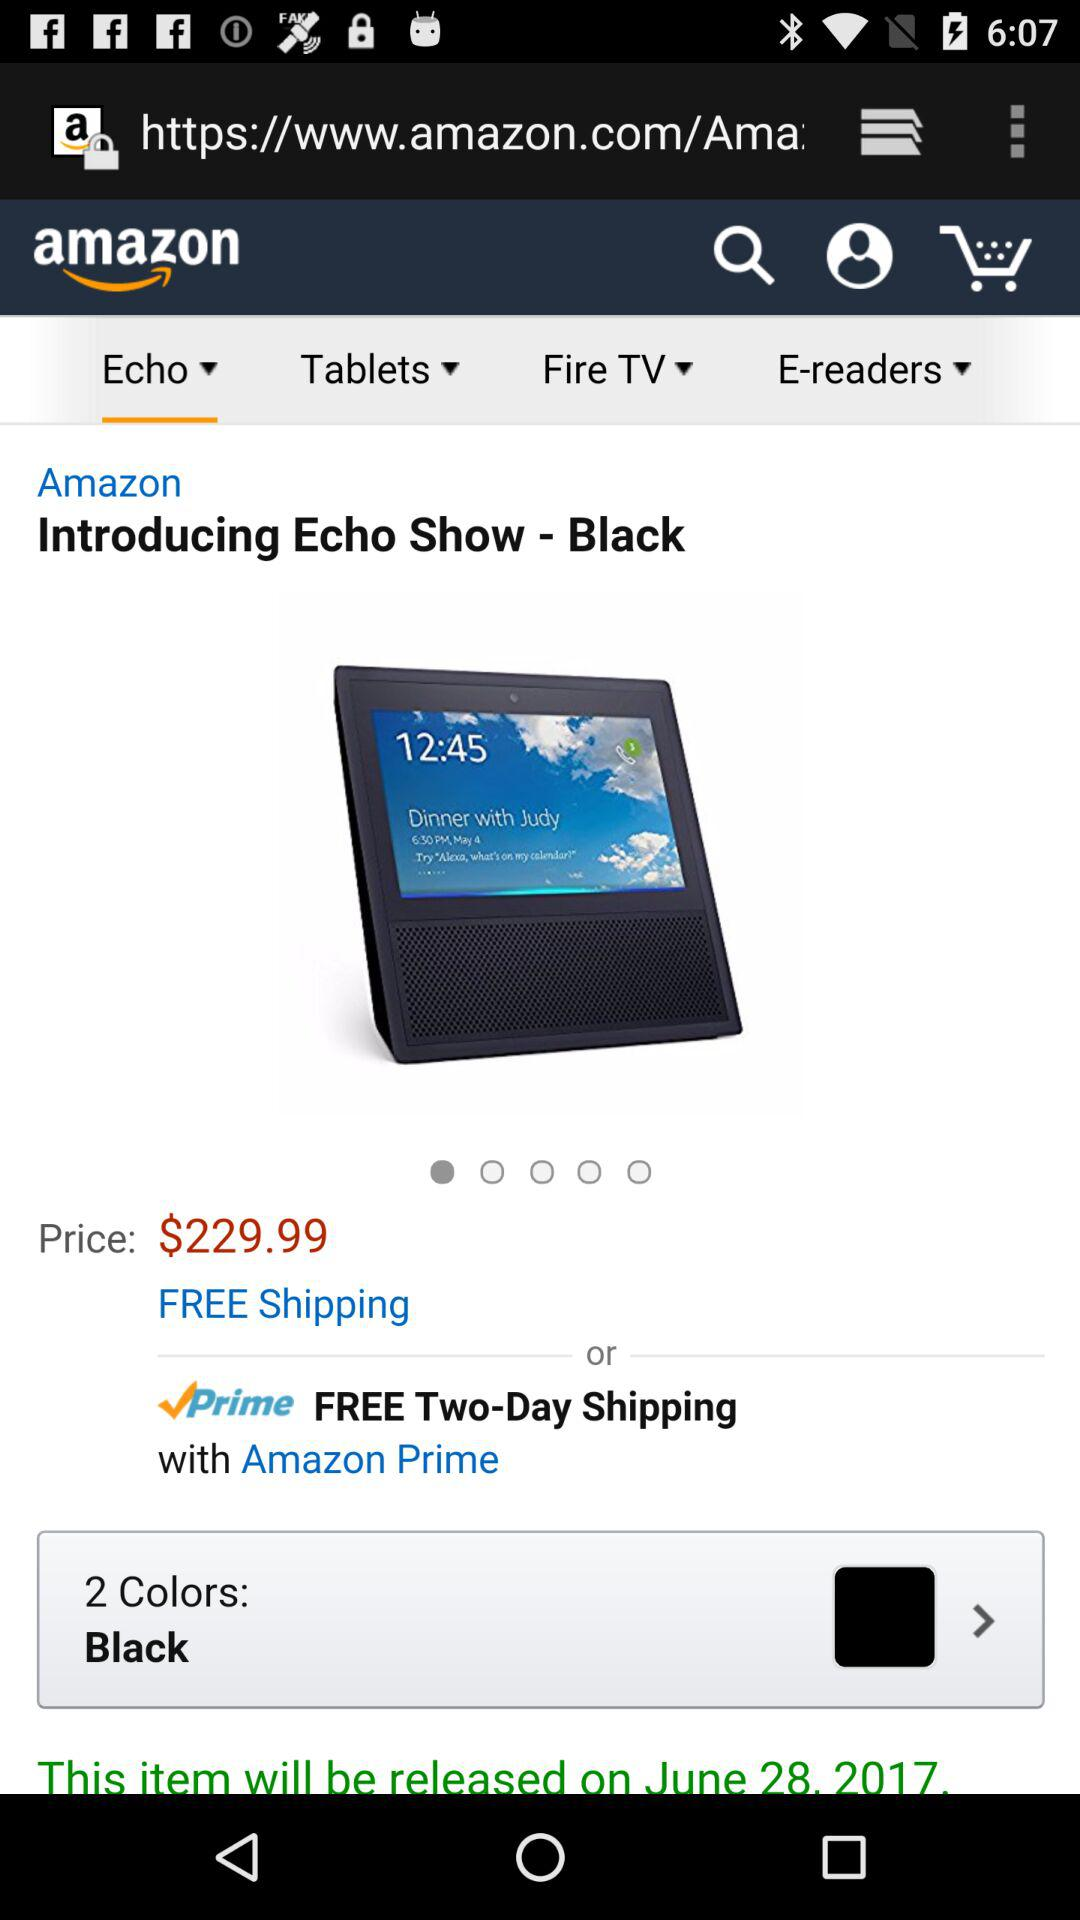What is the number of shipping days? The number of shipping days are "Two". 